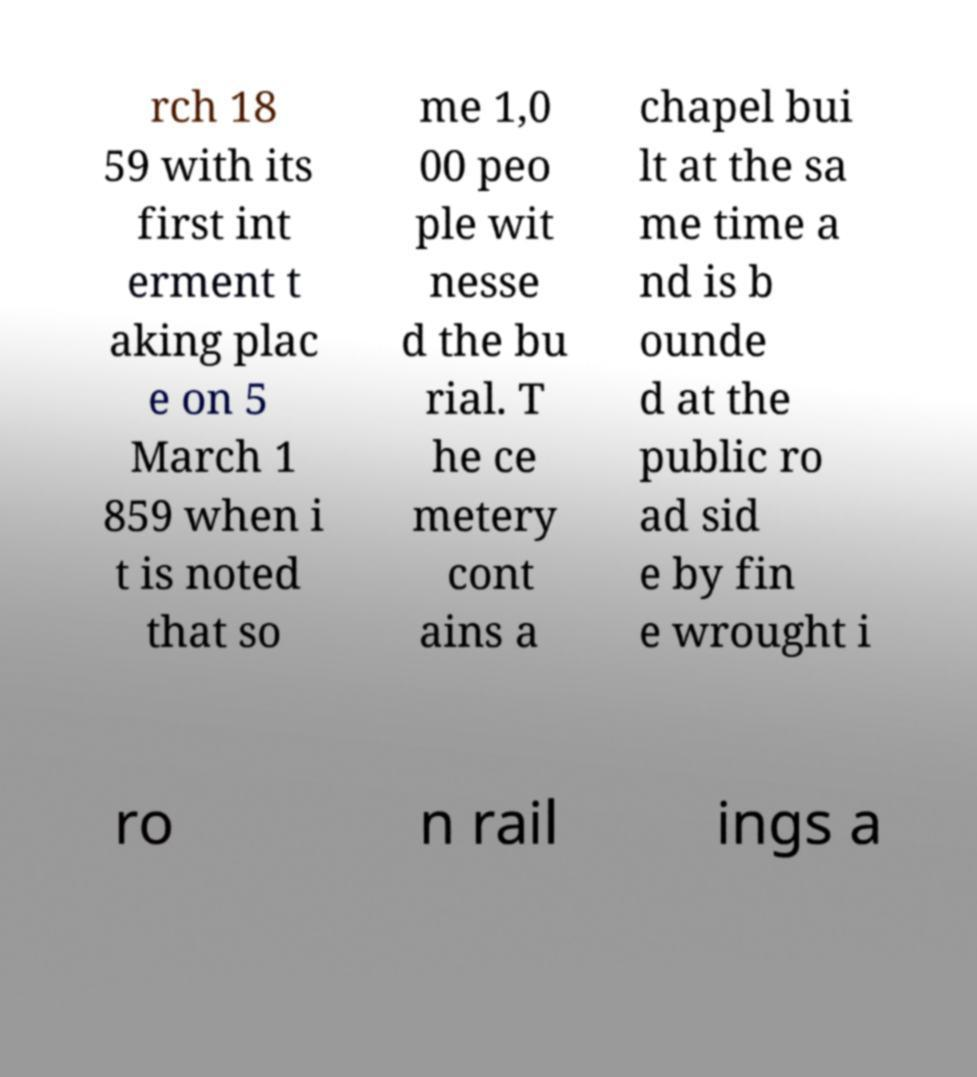I need the written content from this picture converted into text. Can you do that? rch 18 59 with its first int erment t aking plac e on 5 March 1 859 when i t is noted that so me 1,0 00 peo ple wit nesse d the bu rial. T he ce metery cont ains a chapel bui lt at the sa me time a nd is b ounde d at the public ro ad sid e by fin e wrought i ro n rail ings a 